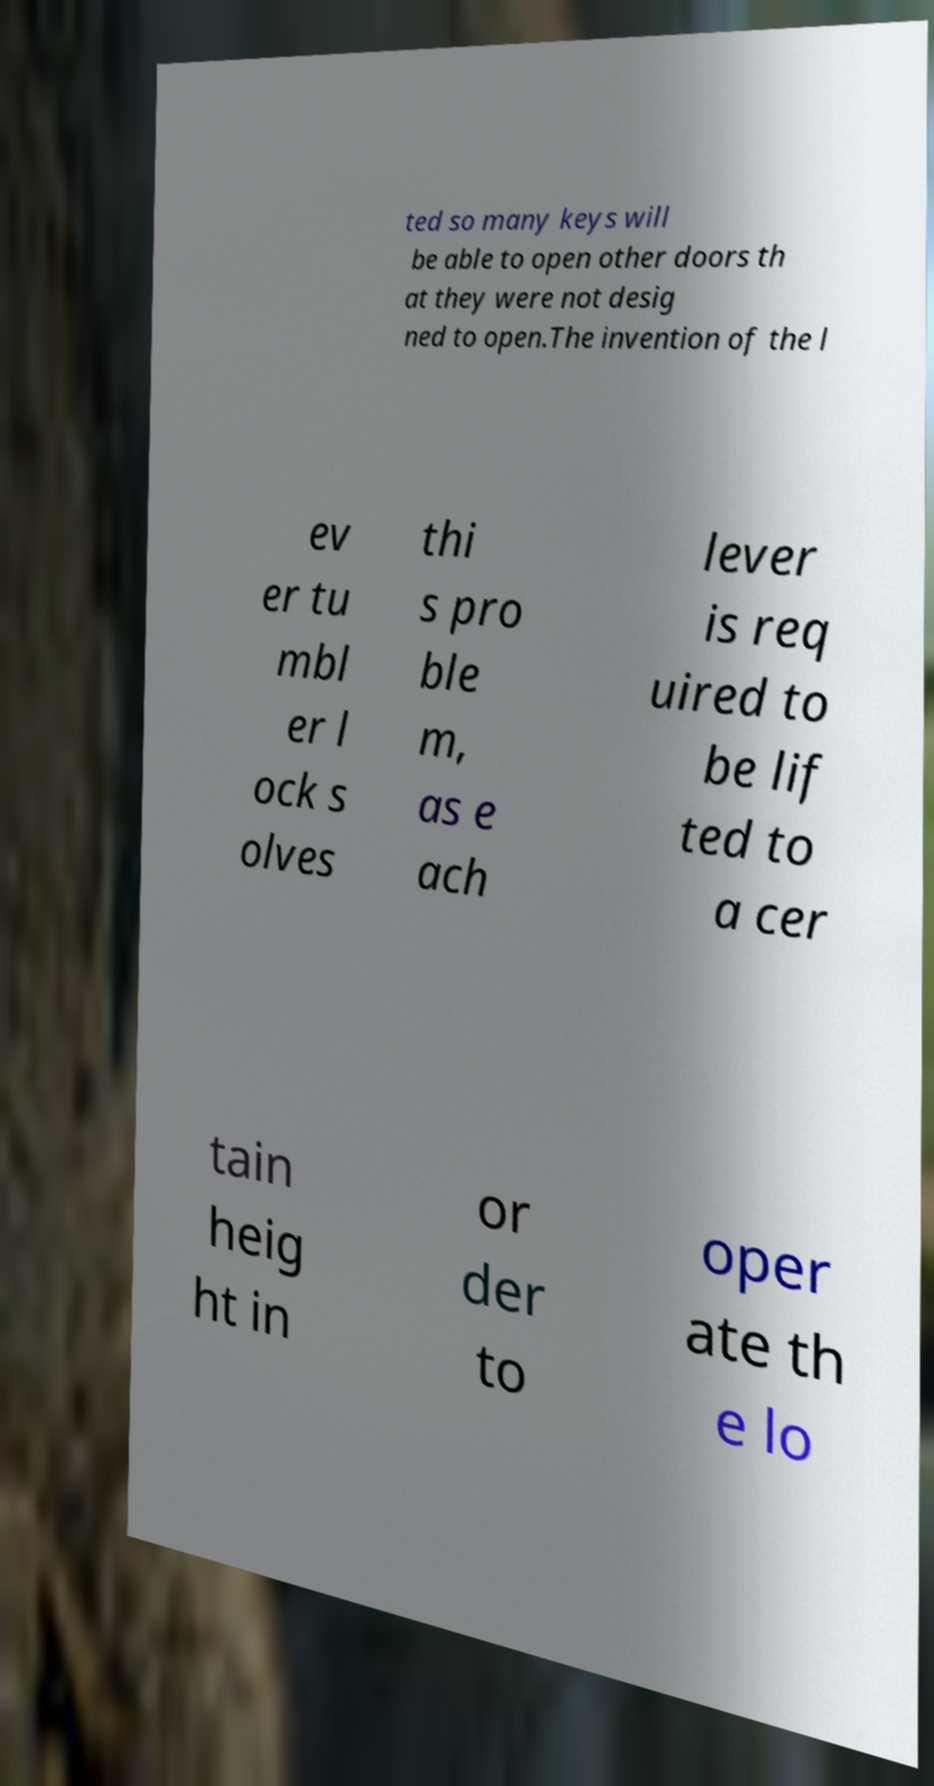Can you accurately transcribe the text from the provided image for me? ted so many keys will be able to open other doors th at they were not desig ned to open.The invention of the l ev er tu mbl er l ock s olves thi s pro ble m, as e ach lever is req uired to be lif ted to a cer tain heig ht in or der to oper ate th e lo 